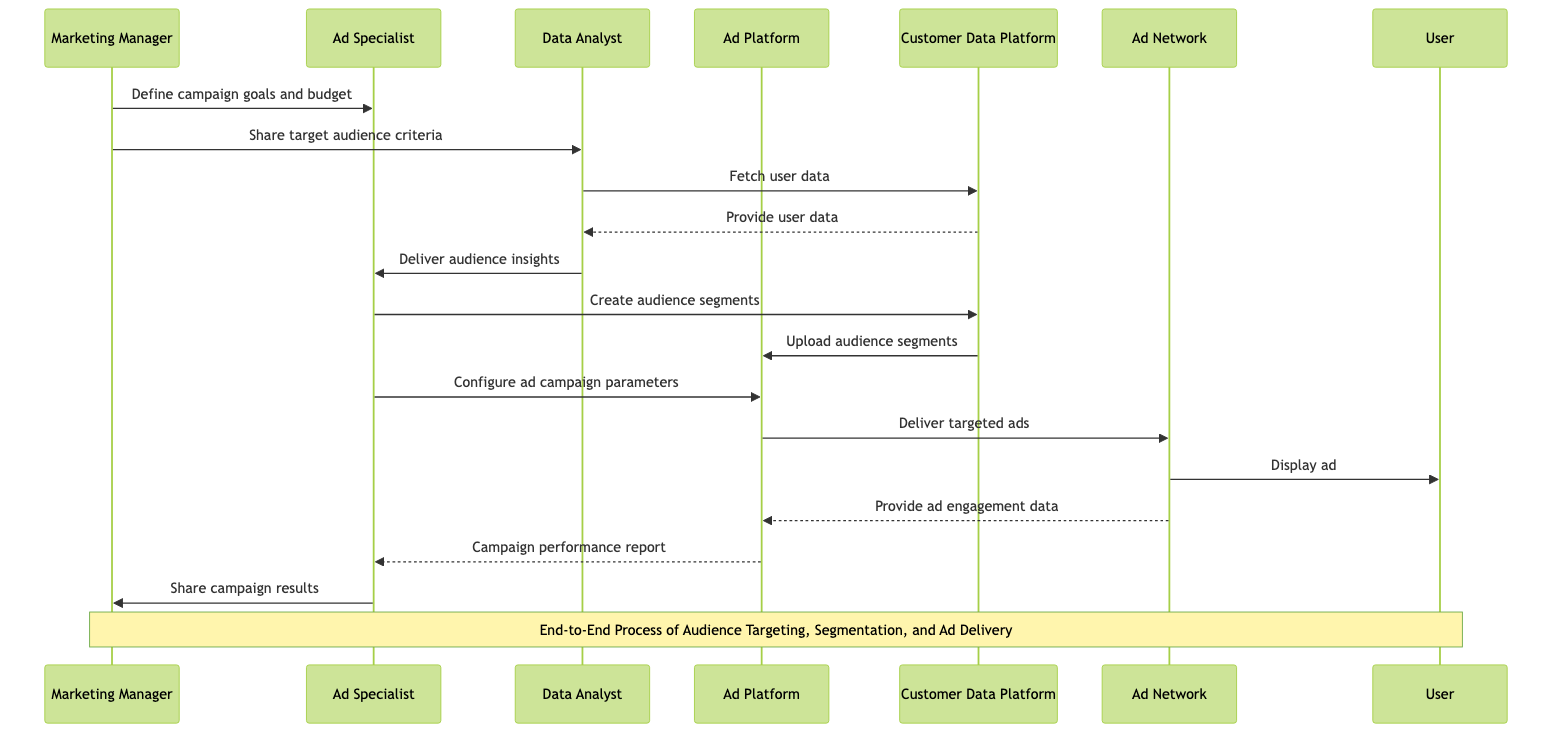What is the first interaction in the diagram? The first interaction in the diagram is between the Marketing Manager and the Ad Specialist, where the Marketing Manager defines campaign goals and budget. This is indicated as the first message in the sequence.
Answer: Define campaign goals and budget How many total participants are involved in this diagram? By counting the unique participants listed, we find there are seven participants: Marketing Manager, Ad Specialist, Data Analyst, Ad Platform, Customer Data Platform, Ad Network, and User.
Answer: 7 Which participant receives the campaign performance report? The Ad Platform is the participant that sends the campaign performance report to the Ad Specialist after gathering the necessary data from the Ad Network. This can be seen as a distinct interaction in the sequence.
Answer: Ad Specialist What is the role of the Data Analyst in the process? The Data Analyst's role includes fetching user data from the Customer Data Platform, delivering audience insights to the Ad Specialist, and indirectly aiding in the audience segmentation process. This involves multiple interactions depicted in the sequence.
Answer: Fetch user data, deliver audience insights How many messages are exchanged between the Ad Specialist and the Marketing Manager? Counting the messages exchanged, there are two between the Ad Specialist and the Marketing Manager: sharing campaign results and defining campaign goals/budget. However, the first message does not go from the Ad Specialist to the Marketing Manager. We must clarify that there is only one message where the Ad Specialist shares campaign results.
Answer: 1 What is the last action in the sequence? The last action in the sequence is when the Ad Specialist shares the campaign results with the Marketing Manager, marking the conclusion of the process as indicated by the final message flow in the diagram.
Answer: Share campaign results What action follows the Ad Specialist creating audience segments? The action that follows the Ad Specialist creating audience segments is the Customer Data Platform uploading those audience segments to the Ad Platform. This can be identified through the sequence of processes.
Answer: Upload audience segments What kind of data does the Ad Network provide back to the Ad Platform? The Ad Network provides ad engagement data back to the Ad Platform. This exchange illustrates the feedback loop between ad delivery and platform performance, as depicted in the interactions.
Answer: Provide ad engagement data 